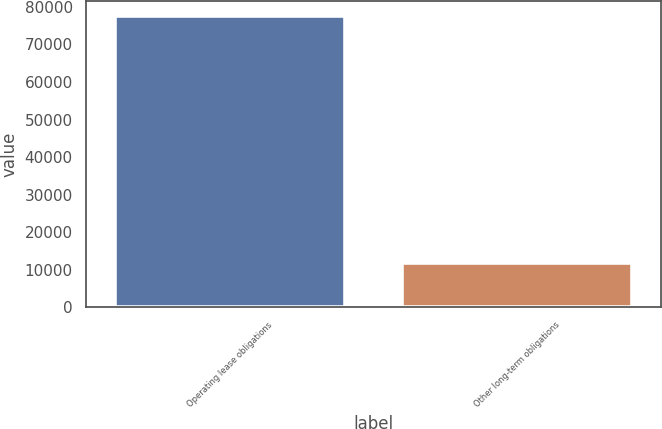Convert chart to OTSL. <chart><loc_0><loc_0><loc_500><loc_500><bar_chart><fcel>Operating lease obligations<fcel>Other long-term obligations<nl><fcel>77701<fcel>11799<nl></chart> 